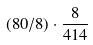<formula> <loc_0><loc_0><loc_500><loc_500>( 8 0 / 8 ) \cdot \frac { 8 } { 4 1 4 }</formula> 